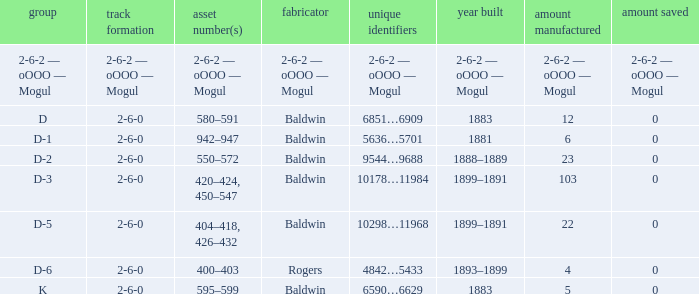What is the wheel arrangement when the year made is 1881? 2-6-0. 